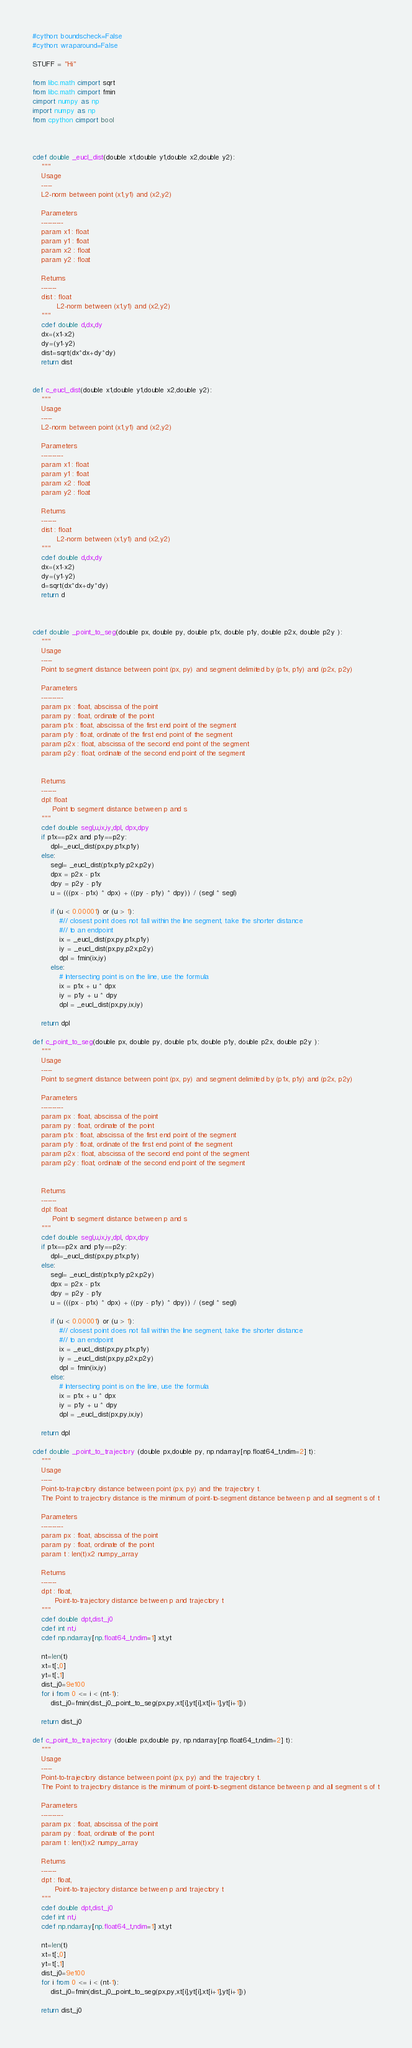Convert code to text. <code><loc_0><loc_0><loc_500><loc_500><_Cython_>#cython: boundscheck=False
#cython: wraparound=False

STUFF = "Hi"

from libc.math cimport sqrt
from libc.math cimport fmin
cimport numpy as np
import numpy as np
from cpython cimport bool



cdef double _eucl_dist(double x1,double y1,double x2,double y2):
    """
    Usage
    -----
    L2-norm between point (x1,y1) and (x2,y2)

    Parameters
    ----------
    param x1 : float
    param y1 : float
    param x2 : float
    param y2 : float

    Returns
    -------
    dist : float
           L2-norm between (x1,y1) and (x2,y2)
    """
    cdef double d,dx,dy
    dx=(x1-x2)
    dy=(y1-y2)
    dist=sqrt(dx*dx+dy*dy)
    return dist


def c_eucl_dist(double x1,double y1,double x2,double y2):
    """
    Usage
    -----
    L2-norm between point (x1,y1) and (x2,y2)

    Parameters
    ----------
    param x1 : float
    param y1 : float
    param x2 : float
    param y2 : float

    Returns
    -------
    dist : float
           L2-norm between (x1,y1) and (x2,y2)
    """
    cdef double d,dx,dy
    dx=(x1-x2)
    dy=(y1-y2)
    d=sqrt(dx*dx+dy*dy)
    return d



cdef double _point_to_seg(double px, double py, double p1x, double p1y, double p2x, double p2y ):
    """
    Usage
    -----
    Point to segment distance between point (px, py) and segment delimited by (p1x, p1y) and (p2x, p2y)

    Parameters
    ----------
    param px : float, abscissa of the point
    param py : float, ordinate of the point
    param p1x : float, abscissa of the first end point of the segment
    param p1y : float, ordinate of the first end point of the segment
    param p2x : float, abscissa of the second end point of the segment
    param p2y : float, ordinate of the second end point of the segment


    Returns
    -------
    dpl: float
         Point to segment distance between p and s
    """
    cdef double segl,u,ix,iy,dpl, dpx,dpy
    if p1x==p2x and p1y==p2y:
        dpl=_eucl_dist(px,py,p1x,p1y)
    else:
        segl= _eucl_dist(p1x,p1y,p2x,p2y)
        dpx = p2x - p1x
        dpy = p2y - p1y
        u = (((px - p1x) * dpx) + ((py - p1y) * dpy)) / (segl * segl)

        if (u < 0.00001) or (u > 1):
            #// closest point does not fall within the line segment, take the shorter distance
            #// to an endpoint
            ix = _eucl_dist(px,py,p1x,p1y)
            iy = _eucl_dist(px,py,p2x,p2y)
            dpl = fmin(ix,iy)
        else:
            # Intersecting point is on the line, use the formula
            ix = p1x + u * dpx
            iy = p1y + u * dpy
            dpl = _eucl_dist(px,py,ix,iy)

    return dpl

def c_point_to_seg(double px, double py, double p1x, double p1y, double p2x, double p2y ):
    """
    Usage
    -----
    Point to segment distance between point (px, py) and segment delimited by (p1x, p1y) and (p2x, p2y)

    Parameters
    ----------
    param px : float, abscissa of the point
    param py : float, ordinate of the point
    param p1x : float, abscissa of the first end point of the segment
    param p1y : float, ordinate of the first end point of the segment
    param p2x : float, abscissa of the second end point of the segment
    param p2y : float, ordinate of the second end point of the segment


    Returns
    -------
    dpl: float
         Point to segment distance between p and s
    """
    cdef double segl,u,ix,iy,dpl, dpx,dpy
    if p1x==p2x and p1y==p2y:
        dpl=_eucl_dist(px,py,p1x,p1y)
    else:
        segl= _eucl_dist(p1x,p1y,p2x,p2y)
        dpx = p2x - p1x
        dpy = p2y - p1y
        u = (((px - p1x) * dpx) + ((py - p1y) * dpy)) / (segl * segl)

        if (u < 0.00001) or (u > 1):
            #// closest point does not fall within the line segment, take the shorter distance
            #// to an endpoint
            ix = _eucl_dist(px,py,p1x,p1y)
            iy = _eucl_dist(px,py,p2x,p2y)
            dpl = fmin(ix,iy)
        else:
            # Intersecting point is on the line, use the formula
            ix = p1x + u * dpx
            iy = p1y + u * dpy
            dpl = _eucl_dist(px,py,ix,iy)

    return dpl

cdef double _point_to_trajectory (double px,double py, np.ndarray[np.float64_t,ndim=2] t):
    """
    Usage
    -----
    Point-to-trajectory distance between point (px, py) and the trajectory t.
    The Point to trajectory distance is the minimum of point-to-segment distance between p and all segment s of t

    Parameters
    ----------
    param px : float, abscissa of the point
    param py : float, ordinate of the point
    param t : len(t)x2 numpy_array

    Returns
    -------
    dpt : float,
          Point-to-trajectory distance between p and trajectory t
    """
    cdef double dpt,dist_j0
    cdef int nt,i
    cdef np.ndarray[np.float64_t,ndim=1] xt,yt

    nt=len(t)
    xt=t[:,0]
    yt=t[:,1]
    dist_j0=9e100
    for i from 0 <= i < (nt-1):
        dist_j0=fmin(dist_j0,_point_to_seg(px,py,xt[i],yt[i],xt[i+1],yt[i+1]))

    return dist_j0

def c_point_to_trajectory (double px,double py, np.ndarray[np.float64_t,ndim=2] t):
    """
    Usage
    -----
    Point-to-trajectory distance between point (px, py) and the trajectory t.
    The Point to trajectory distance is the minimum of point-to-segment distance between p and all segment s of t

    Parameters
    ----------
    param px : float, abscissa of the point
    param py : float, ordinate of the point
    param t : len(t)x2 numpy_array

    Returns
    -------
    dpt : float,
          Point-to-trajectory distance between p and trajectory t
    """
    cdef double dpt,dist_j0
    cdef int nt,i
    cdef np.ndarray[np.float64_t,ndim=1] xt,yt

    nt=len(t)
    xt=t[:,0]
    yt=t[:,1]
    dist_j0=9e100
    for i from 0 <= i < (nt-1):
        dist_j0=fmin(dist_j0,_point_to_seg(px,py,xt[i],yt[i],xt[i+1],yt[i+1]))

    return dist_j0
</code> 